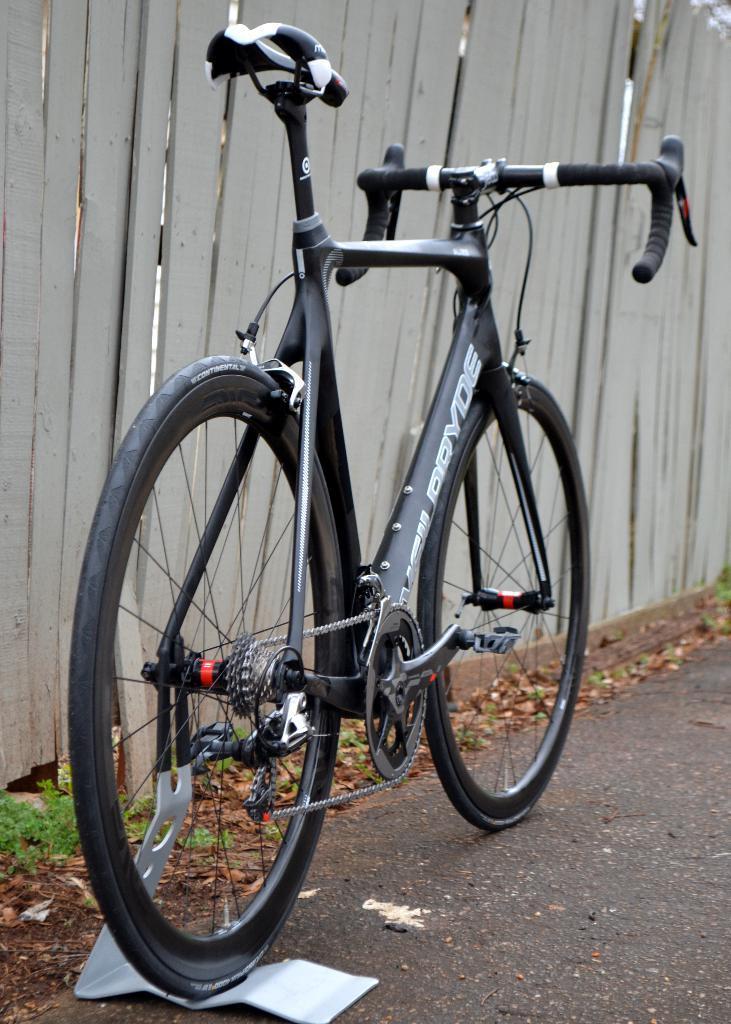Describe this image in one or two sentences. In this image, we can see a bicycle with stand on the road. Background there is wooden fencing. Here we can see few plants. 